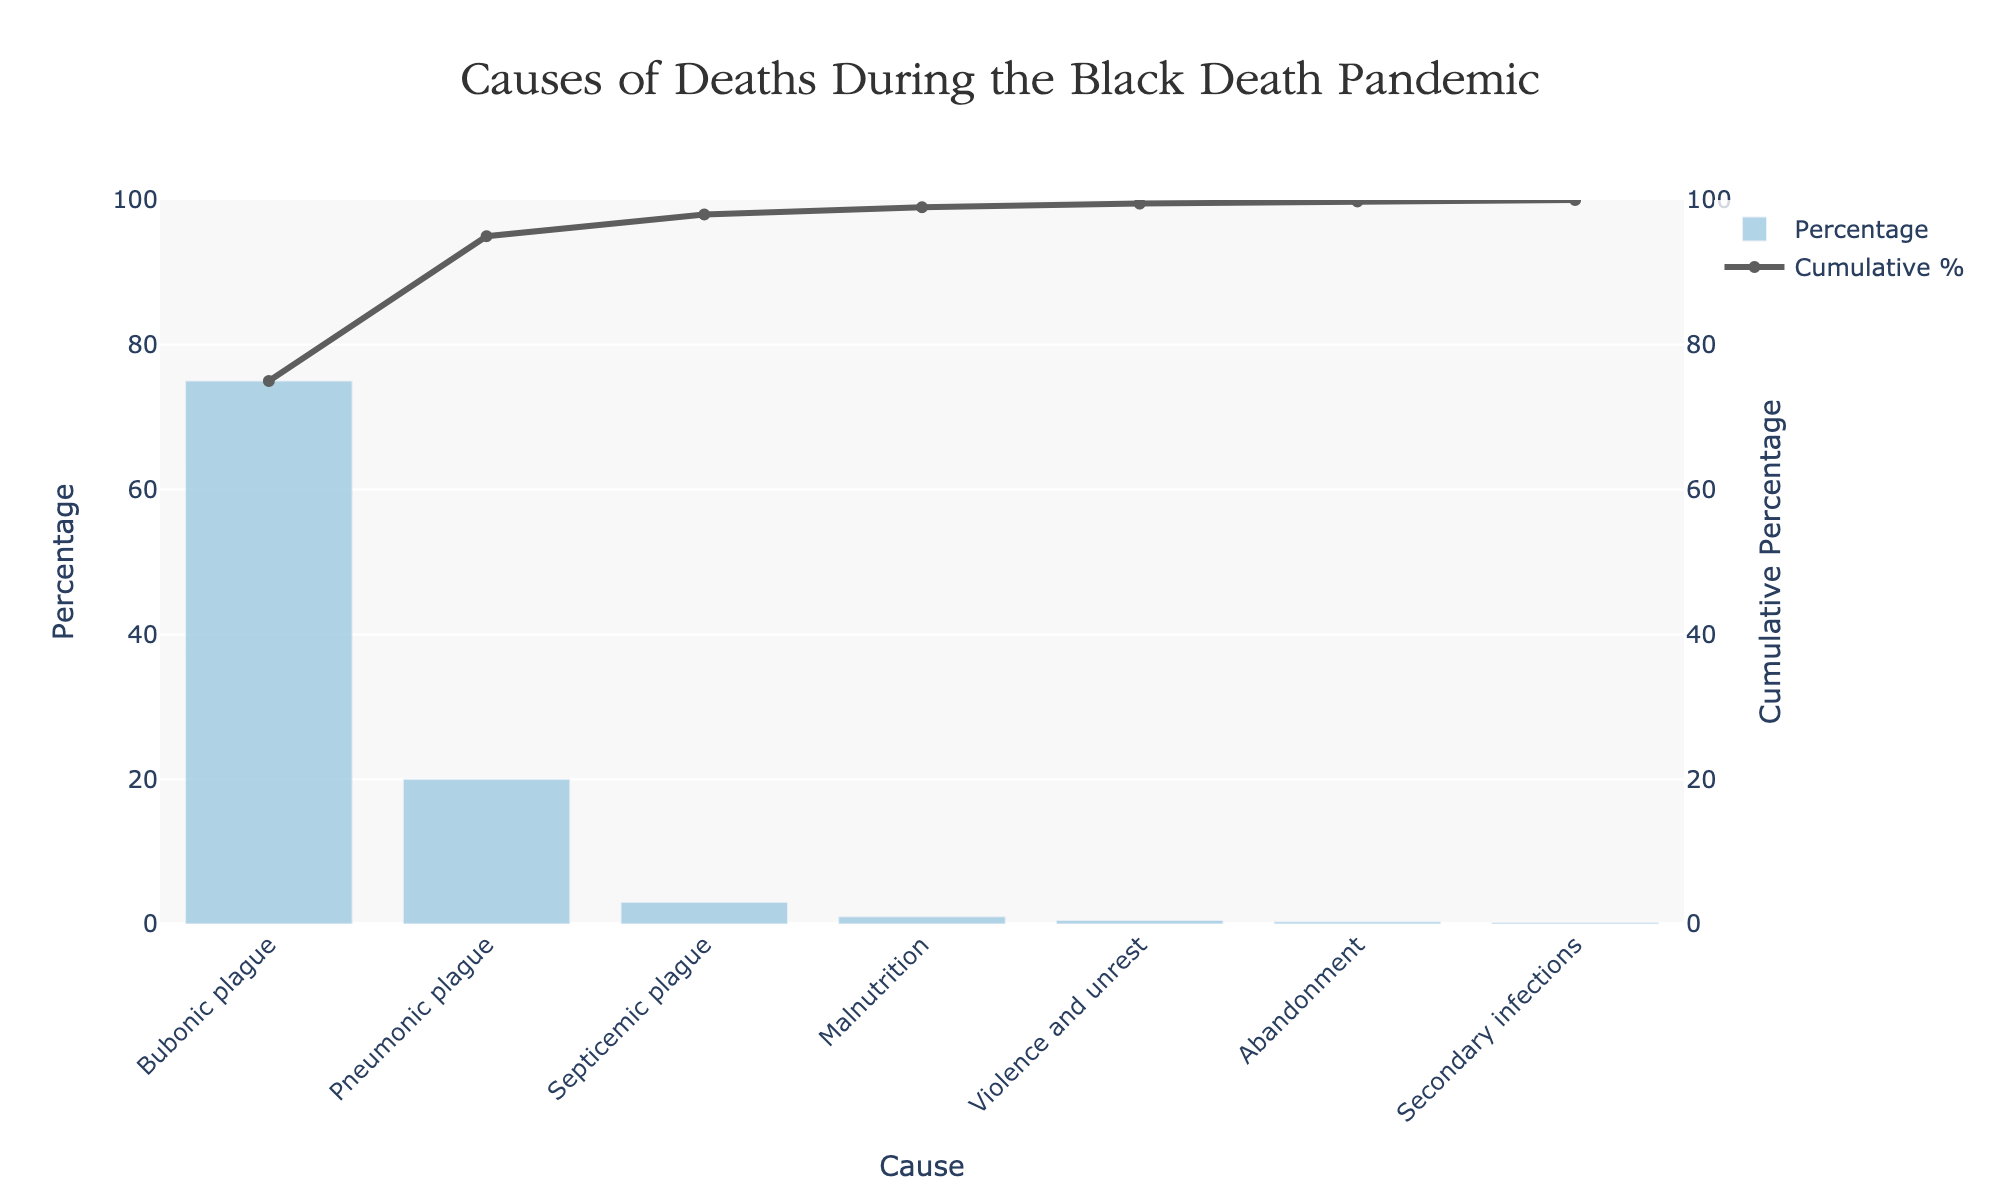What is the title of the chart? The title of the chart is displayed at the top center of the figure. It reads, "Causes of Deaths During the Black Death Pandemic."
Answer: Causes of Deaths During the Black Death Pandemic Which cause of death has the highest percentage? The chart shows bars representing various causes of death by percentage. The highest bar represents the cause "Bubonic plague" with 75%.
Answer: Bubonic plague What is the cumulative percentage up to "Septicemic plague"? The cumulative percentage column adds up the percentages as they go down the list. Up to "Septicemic plague," the cumulative percentage is the sum of Bubonic plague (75%), Pneumonic plague (20%), and Septicemic plague (3%). Thus, 75 + 20 + 3 = 98%.
Answer: 98% What is the least common cause of death on the chart? The shortest bar on the chart represents the least common cause of death. It is "Secondary infections" with a percentage of 0.2%.
Answer: Secondary infections By how much does the percentage of deaths from Bubonic plague exceed that from Pneumonic plague? The percentage of deaths from Bubonic plague is 75%, and from Pneumonic plague, it is 20%. The difference is 75 - 20 = 55%.
Answer: 55% How many causes are listed in the figure? Each bar represents a different cause of death. Counting the bars, we find there are 7 causes listed in the figure.
Answer: 7 What is the cumulative percentage at "Violence and unrest"? The cumulative percentage column shows the addition of all percentages up to "Violence and unrest." Adding Bubonic plague (75%), Pneumonic plague (20%), Septicemic plague (3%), and Malnutrition (1%) gives us 75 + 20 + 3 + 1 + 0.5 = 99.5%.
Answer: 99.5% What is the second most common cause of death? The second highest bar on the chart represents "Pneumonic plague," which has a percentage of 20%.
Answer: Pneumonic plague What percentage of deaths is attributed to causes other than the three types of plague? The percentages labeled with causes other than Bubonic, Pneumonic, and Septicemic plagues are Malnutrition, Violence and unrest, Abandonment, and Secondary infections. Summing them up gives 1% + 0.5% + 0.3% + 0.2% = 2%.
Answer: 2% How much does the cumulative percentage increase from "Abandonment" to "Secondary infections"? The cumulative percentage at Abandonment is the addition of all previous ones, so it’s 75 + 20 + 3 + 1 + 0.5 + 0.3 = 100.8%. For Secondary Infections, it's 100.8% + 0.2% = 101%. The increase is 101% - 100.8% = 0.2%.
Answer: 0.2% 